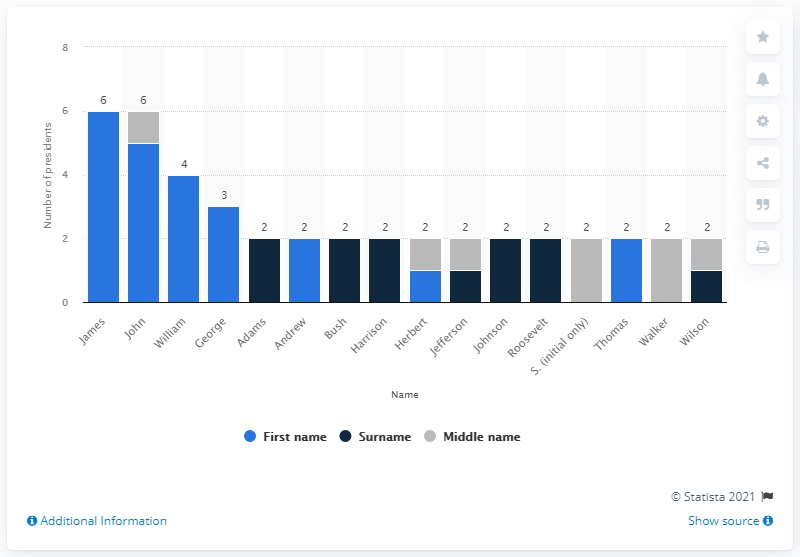What is the second most common first name for a U.S. president? The second most common first name for a U.S. president is William, shared by William Henry Harrison, William McKinley, William Howard Taft, and William J. Clinton, making it the first name of four U.S. presidents. 